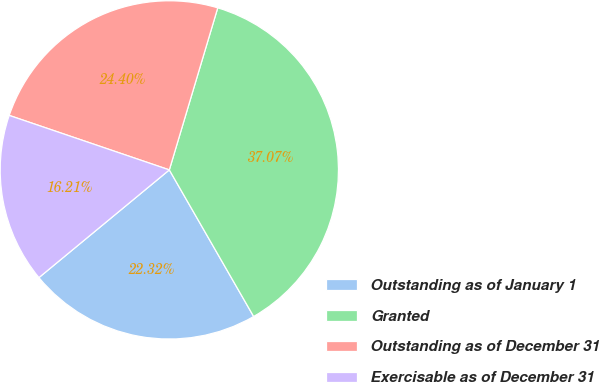<chart> <loc_0><loc_0><loc_500><loc_500><pie_chart><fcel>Outstanding as of January 1<fcel>Granted<fcel>Outstanding as of December 31<fcel>Exercisable as of December 31<nl><fcel>22.32%<fcel>37.07%<fcel>24.4%<fcel>16.21%<nl></chart> 